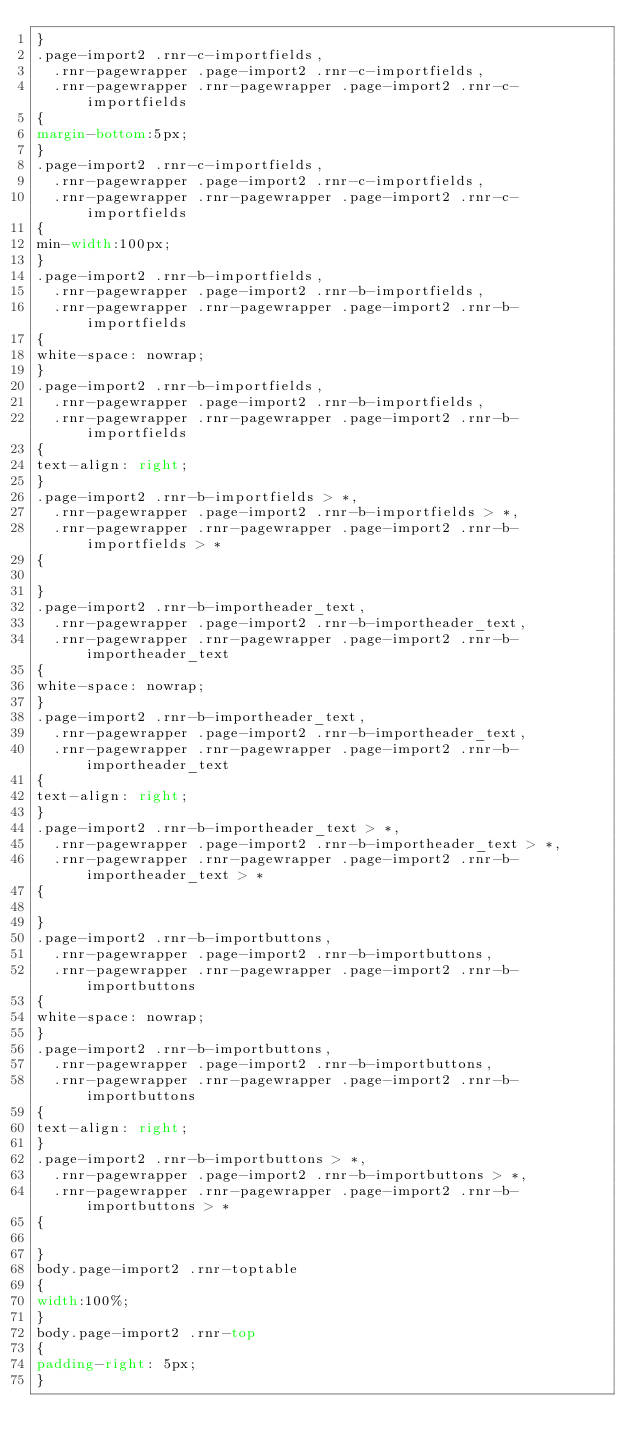Convert code to text. <code><loc_0><loc_0><loc_500><loc_500><_CSS_>}
.page-import2 .rnr-c-importfields,
  .rnr-pagewrapper .page-import2 .rnr-c-importfields,
  .rnr-pagewrapper .rnr-pagewrapper .page-import2 .rnr-c-importfields
{
margin-bottom:5px;
}
.page-import2 .rnr-c-importfields,
  .rnr-pagewrapper .page-import2 .rnr-c-importfields,
  .rnr-pagewrapper .rnr-pagewrapper .page-import2 .rnr-c-importfields
{
min-width:100px;
}
.page-import2 .rnr-b-importfields,
  .rnr-pagewrapper .page-import2 .rnr-b-importfields,
  .rnr-pagewrapper .rnr-pagewrapper .page-import2 .rnr-b-importfields
{
white-space: nowrap;
}
.page-import2 .rnr-b-importfields,
  .rnr-pagewrapper .page-import2 .rnr-b-importfields,
  .rnr-pagewrapper .rnr-pagewrapper .page-import2 .rnr-b-importfields
{
text-align: right;
}
.page-import2 .rnr-b-importfields > *,
  .rnr-pagewrapper .page-import2 .rnr-b-importfields > *,
  .rnr-pagewrapper .rnr-pagewrapper .page-import2 .rnr-b-importfields > *
{

}
.page-import2 .rnr-b-importheader_text,
  .rnr-pagewrapper .page-import2 .rnr-b-importheader_text,
  .rnr-pagewrapper .rnr-pagewrapper .page-import2 .rnr-b-importheader_text
{
white-space: nowrap;
}
.page-import2 .rnr-b-importheader_text,
  .rnr-pagewrapper .page-import2 .rnr-b-importheader_text,
  .rnr-pagewrapper .rnr-pagewrapper .page-import2 .rnr-b-importheader_text
{
text-align: right;
}
.page-import2 .rnr-b-importheader_text > *,
  .rnr-pagewrapper .page-import2 .rnr-b-importheader_text > *,
  .rnr-pagewrapper .rnr-pagewrapper .page-import2 .rnr-b-importheader_text > *
{

}
.page-import2 .rnr-b-importbuttons,
  .rnr-pagewrapper .page-import2 .rnr-b-importbuttons,
  .rnr-pagewrapper .rnr-pagewrapper .page-import2 .rnr-b-importbuttons
{
white-space: nowrap;
}
.page-import2 .rnr-b-importbuttons,
  .rnr-pagewrapper .page-import2 .rnr-b-importbuttons,
  .rnr-pagewrapper .rnr-pagewrapper .page-import2 .rnr-b-importbuttons
{
text-align: right;
}
.page-import2 .rnr-b-importbuttons > *,
  .rnr-pagewrapper .page-import2 .rnr-b-importbuttons > *,
  .rnr-pagewrapper .rnr-pagewrapper .page-import2 .rnr-b-importbuttons > *
{

}
body.page-import2 .rnr-toptable
{
width:100%;
}
body.page-import2 .rnr-top
{
padding-right: 5px;
}
</code> 